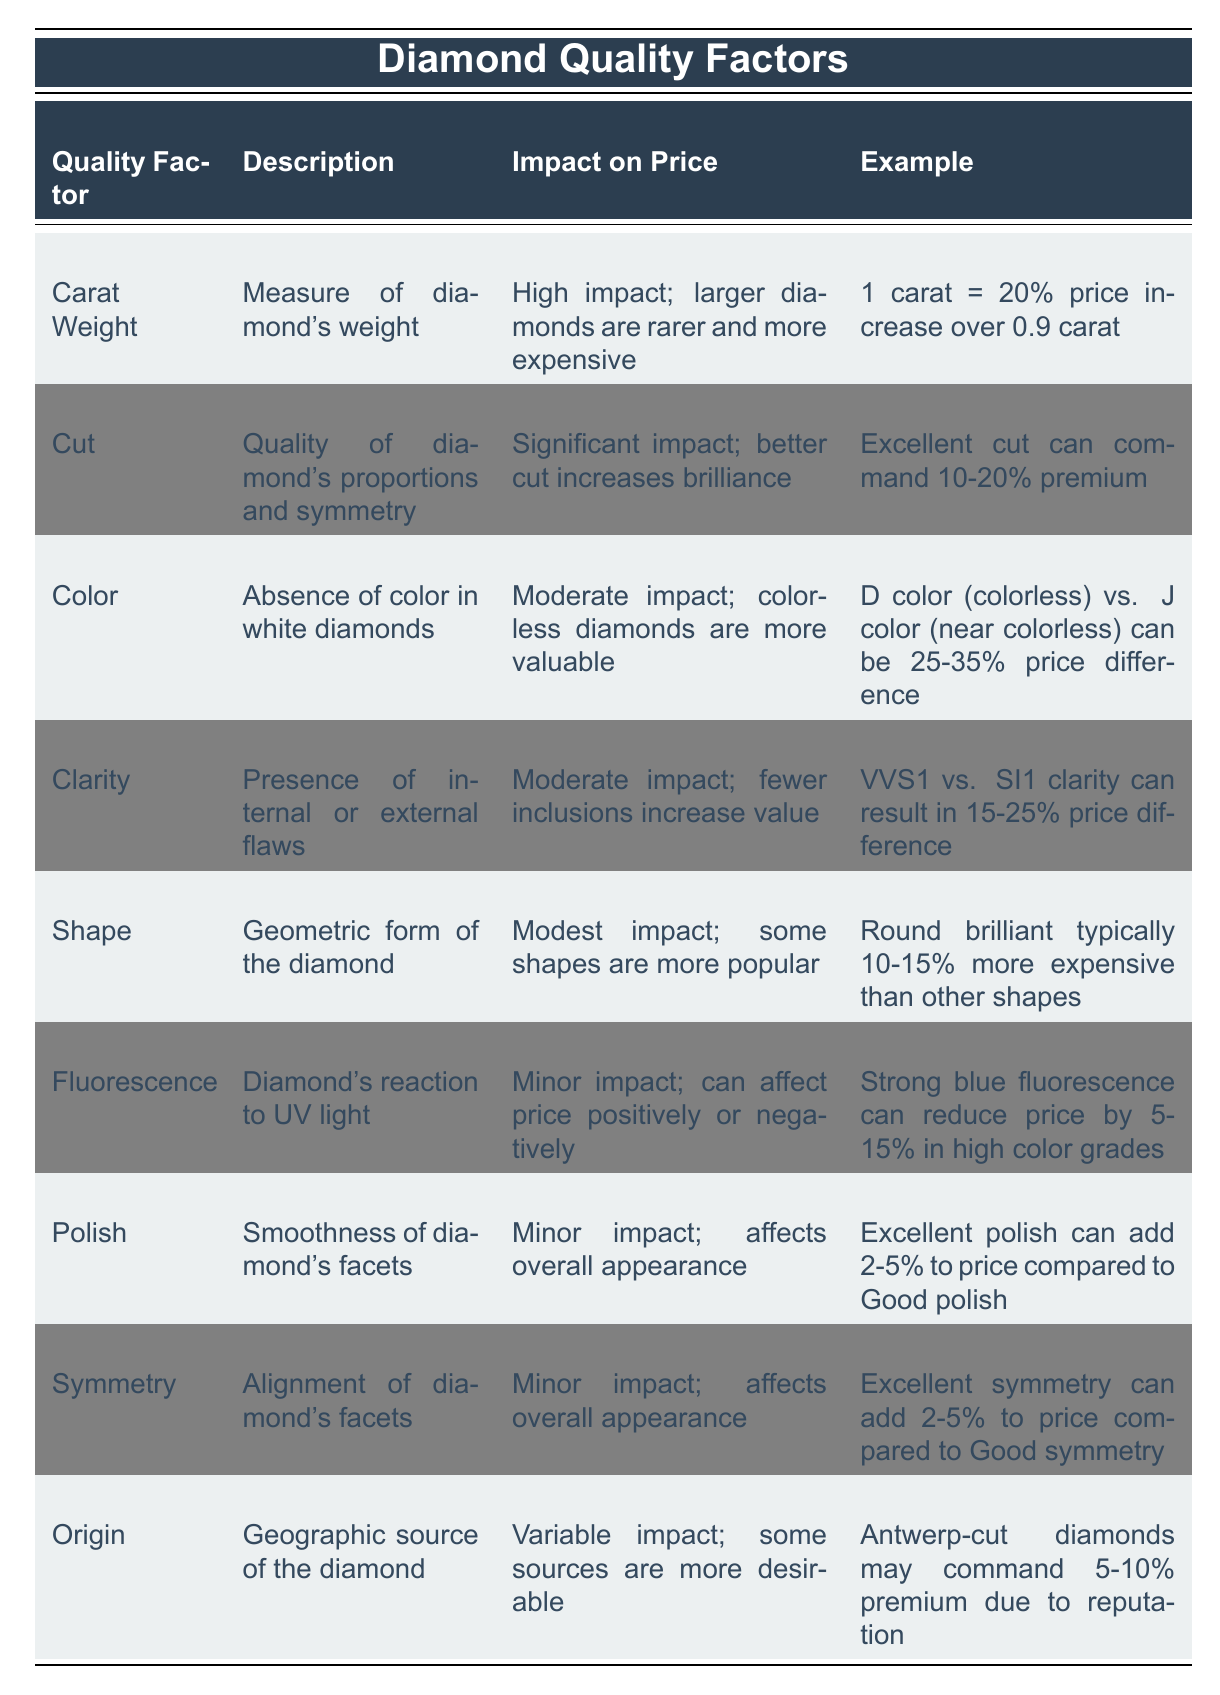What is the description of Carat Weight? The table specifies that Carat Weight is defined as the measure of a diamond's weight.
Answer: Measure of diamond's weight Which quality factor has a high impact on price? From the table, Carat Weight is noted to have a high impact on price because larger diamonds are rarer and more expensive.
Answer: Carat Weight How much price difference can be expected between D color and J color diamonds? The table states that the price difference can be between 25-35% between D color (colorless) and J color (near colorless).
Answer: 25-35% If a diamond's cut is rated as excellent, what premium can it command? The table indicates that an excellent cut diamond can command a premium of 10-20% over lower-rated cuts.
Answer: 10-20% True or False: The shape of a diamond has a significant impact on price. The table specifies that the shape of the diamond has a modest impact on price, thus making the statement false.
Answer: False What percentage increase in price is observed when comparing a 1-carat diamond to a 0.9-carat diamond? The table shows that there is a 20% price increase for a 1-carat diamond compared to a 0.9-carat diamond.
Answer: 20% Which quality factor could reduce the price by 5-15% for diamonds with high color grades? According to the table, strong blue fluorescence can reduce the price by 5-15% in high color grades.
Answer: Strong blue fluorescence If a diamond has VVS1 clarity, how does its price compare to an SI1 clarity diamond? The table shows that there can be a 15-25% price difference, with VVS1 clarity being more valuable than SI1 clarity.
Answer: 15-25% What is the impact of excellent polish on diamond price compared to good polish? The table states that excellent polish can add 2-5% to the price compared to good polish.
Answer: 2-5% Which origin may command a premium due to its reputation? The table mentions that Antwerp-cut diamonds may command a 5-10% premium due to their reputation.
Answer: Antwerp-cut diamonds 